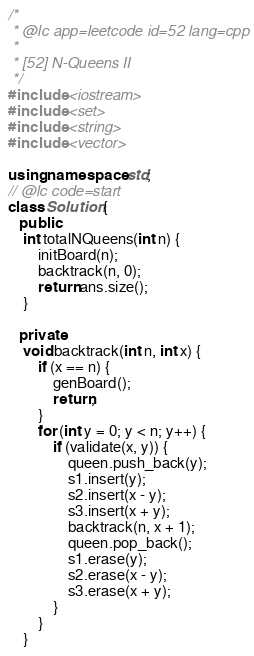<code> <loc_0><loc_0><loc_500><loc_500><_C++_>/*
 * @lc app=leetcode id=52 lang=cpp
 *
 * [52] N-Queens II
 */
#include <iostream>
#include <set>
#include <string>
#include <vector>

using namespace std;
// @lc code=start
class Solution {
   public:
    int totalNQueens(int n) {
        initBoard(n);
        backtrack(n, 0);
        return ans.size();
    }

   private:
    void backtrack(int n, int x) {
        if (x == n) {
            genBoard();
            return;
        }
        for (int y = 0; y < n; y++) {
            if (validate(x, y)) {
                queen.push_back(y);
                s1.insert(y);
                s2.insert(x - y);
                s3.insert(x + y);
                backtrack(n, x + 1);
                queen.pop_back();
                s1.erase(y);
                s2.erase(x - y);
                s3.erase(x + y);
            }
        }
    }
</code> 